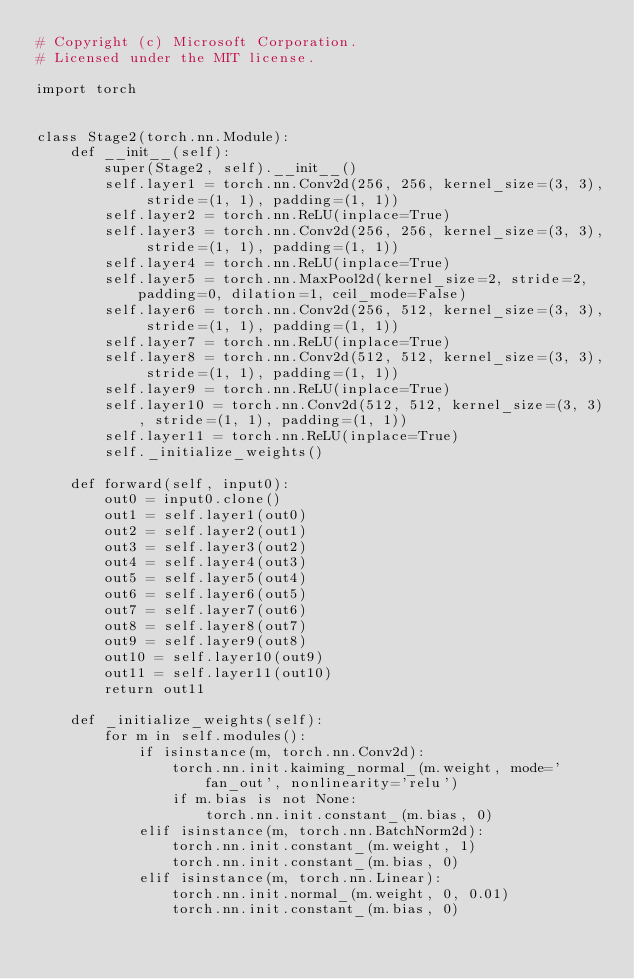Convert code to text. <code><loc_0><loc_0><loc_500><loc_500><_Python_># Copyright (c) Microsoft Corporation.
# Licensed under the MIT license.

import torch


class Stage2(torch.nn.Module):
    def __init__(self):
        super(Stage2, self).__init__()
        self.layer1 = torch.nn.Conv2d(256, 256, kernel_size=(3, 3), stride=(1, 1), padding=(1, 1))
        self.layer2 = torch.nn.ReLU(inplace=True)
        self.layer3 = torch.nn.Conv2d(256, 256, kernel_size=(3, 3), stride=(1, 1), padding=(1, 1))
        self.layer4 = torch.nn.ReLU(inplace=True)
        self.layer5 = torch.nn.MaxPool2d(kernel_size=2, stride=2, padding=0, dilation=1, ceil_mode=False)
        self.layer6 = torch.nn.Conv2d(256, 512, kernel_size=(3, 3), stride=(1, 1), padding=(1, 1))
        self.layer7 = torch.nn.ReLU(inplace=True)
        self.layer8 = torch.nn.Conv2d(512, 512, kernel_size=(3, 3), stride=(1, 1), padding=(1, 1))
        self.layer9 = torch.nn.ReLU(inplace=True)
        self.layer10 = torch.nn.Conv2d(512, 512, kernel_size=(3, 3), stride=(1, 1), padding=(1, 1))
        self.layer11 = torch.nn.ReLU(inplace=True)
        self._initialize_weights()

    def forward(self, input0):
        out0 = input0.clone()
        out1 = self.layer1(out0)
        out2 = self.layer2(out1)
        out3 = self.layer3(out2)
        out4 = self.layer4(out3)
        out5 = self.layer5(out4)
        out6 = self.layer6(out5)
        out7 = self.layer7(out6)
        out8 = self.layer8(out7)
        out9 = self.layer9(out8)
        out10 = self.layer10(out9)
        out11 = self.layer11(out10)
        return out11

    def _initialize_weights(self):
        for m in self.modules():
            if isinstance(m, torch.nn.Conv2d):
                torch.nn.init.kaiming_normal_(m.weight, mode='fan_out', nonlinearity='relu')
                if m.bias is not None:
                    torch.nn.init.constant_(m.bias, 0)
            elif isinstance(m, torch.nn.BatchNorm2d):
                torch.nn.init.constant_(m.weight, 1)
                torch.nn.init.constant_(m.bias, 0)
            elif isinstance(m, torch.nn.Linear):
                torch.nn.init.normal_(m.weight, 0, 0.01)
                torch.nn.init.constant_(m.bias, 0)
</code> 